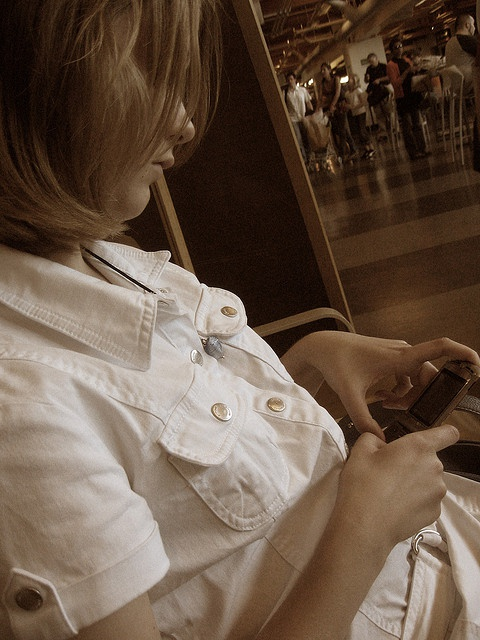Describe the objects in this image and their specific colors. I can see people in black, darkgray, gray, and maroon tones, chair in black, maroon, and gray tones, cell phone in black, maroon, and gray tones, people in black, maroon, and gray tones, and people in black, maroon, and gray tones in this image. 